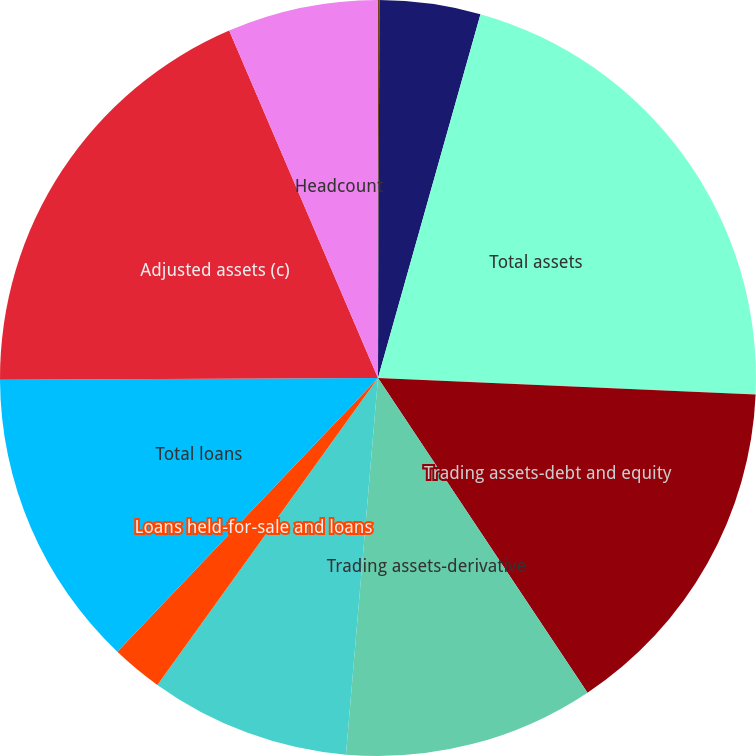Convert chart. <chart><loc_0><loc_0><loc_500><loc_500><pie_chart><fcel>(in millions except headcount)<fcel>Equity<fcel>Total assets<fcel>Trading assets-debt and equity<fcel>Trading assets-derivative<fcel>Loans retained (b)<fcel>Loans held-for-sale and loans<fcel>Total loans<fcel>Adjusted assets (c)<fcel>Headcount<nl><fcel>0.06%<fcel>4.31%<fcel>21.33%<fcel>14.95%<fcel>10.7%<fcel>8.57%<fcel>2.19%<fcel>12.82%<fcel>18.63%<fcel>6.44%<nl></chart> 